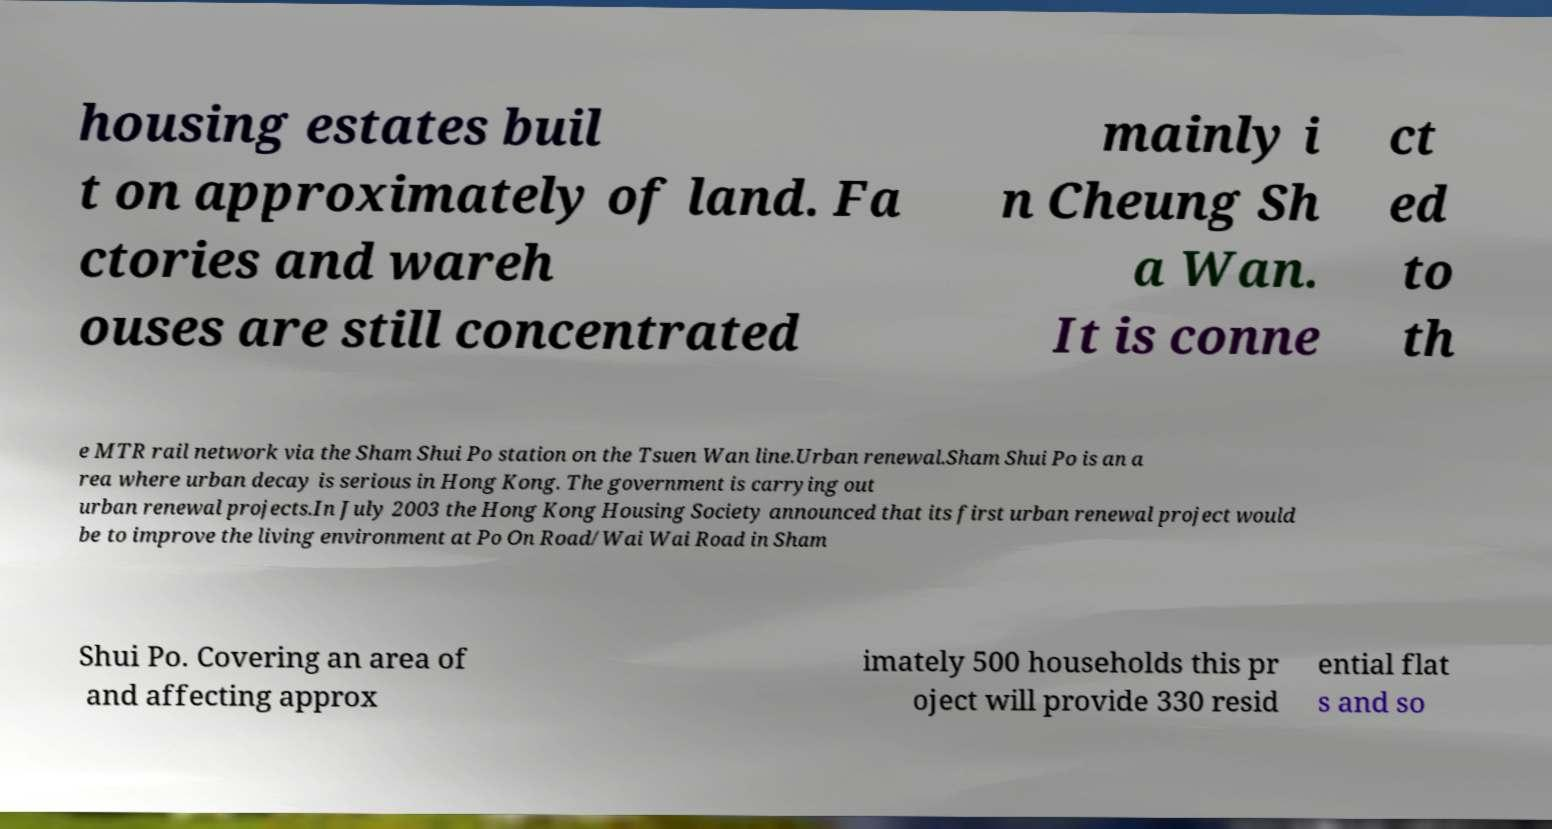What messages or text are displayed in this image? I need them in a readable, typed format. housing estates buil t on approximately of land. Fa ctories and wareh ouses are still concentrated mainly i n Cheung Sh a Wan. It is conne ct ed to th e MTR rail network via the Sham Shui Po station on the Tsuen Wan line.Urban renewal.Sham Shui Po is an a rea where urban decay is serious in Hong Kong. The government is carrying out urban renewal projects.In July 2003 the Hong Kong Housing Society announced that its first urban renewal project would be to improve the living environment at Po On Road/Wai Wai Road in Sham Shui Po. Covering an area of and affecting approx imately 500 households this pr oject will provide 330 resid ential flat s and so 